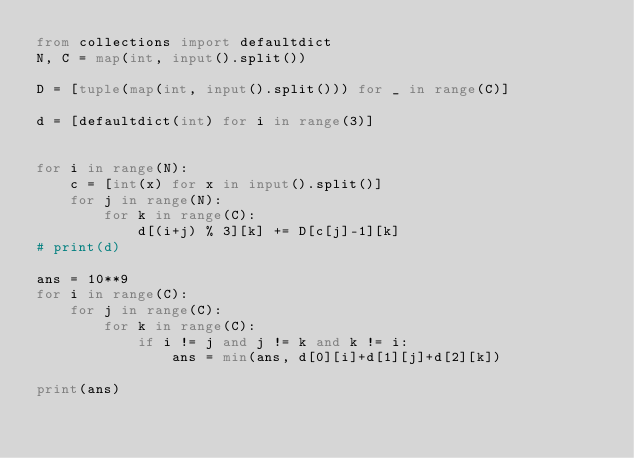Convert code to text. <code><loc_0><loc_0><loc_500><loc_500><_Python_>from collections import defaultdict
N, C = map(int, input().split())

D = [tuple(map(int, input().split())) for _ in range(C)]

d = [defaultdict(int) for i in range(3)]


for i in range(N):
    c = [int(x) for x in input().split()]
    for j in range(N):
        for k in range(C):
            d[(i+j) % 3][k] += D[c[j]-1][k]
# print(d)

ans = 10**9
for i in range(C):
    for j in range(C):
        for k in range(C):
            if i != j and j != k and k != i:
                ans = min(ans, d[0][i]+d[1][j]+d[2][k])

print(ans)
</code> 